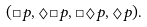Convert formula to latex. <formula><loc_0><loc_0><loc_500><loc_500>( \Box p , \Diamond \Box p , \Box \Diamond p , \Diamond p ) .</formula> 